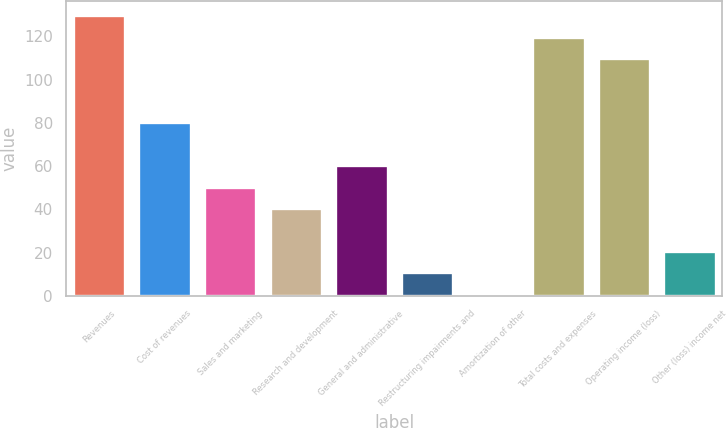Convert chart. <chart><loc_0><loc_0><loc_500><loc_500><bar_chart><fcel>Revenues<fcel>Cost of revenues<fcel>Sales and marketing<fcel>Research and development<fcel>General and administrative<fcel>Restructuring impairments and<fcel>Amortization of other<fcel>Total costs and expenses<fcel>Operating income (loss)<fcel>Other (loss) income net<nl><fcel>129.7<fcel>80.2<fcel>50.5<fcel>40.6<fcel>60.4<fcel>10.9<fcel>1<fcel>119.8<fcel>109.9<fcel>20.8<nl></chart> 